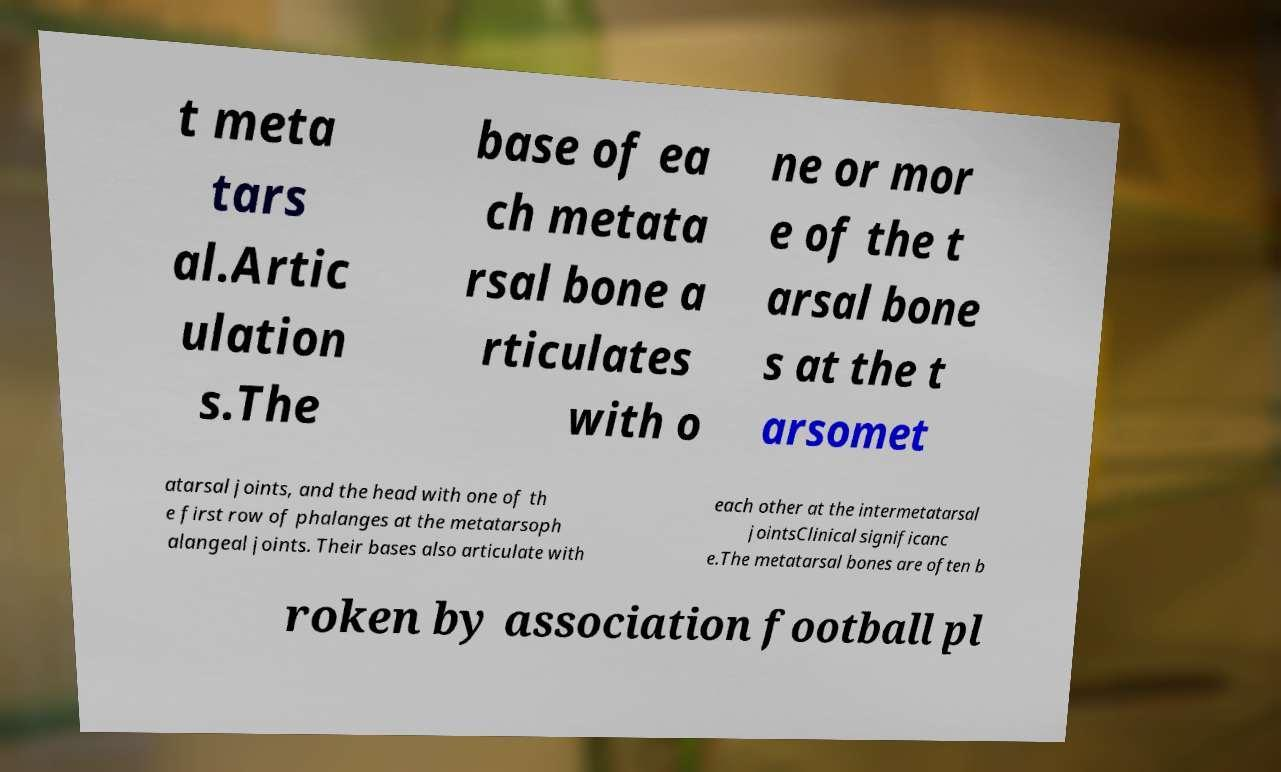Could you assist in decoding the text presented in this image and type it out clearly? t meta tars al.Artic ulation s.The base of ea ch metata rsal bone a rticulates with o ne or mor e of the t arsal bone s at the t arsomet atarsal joints, and the head with one of th e first row of phalanges at the metatarsoph alangeal joints. Their bases also articulate with each other at the intermetatarsal jointsClinical significanc e.The metatarsal bones are often b roken by association football pl 